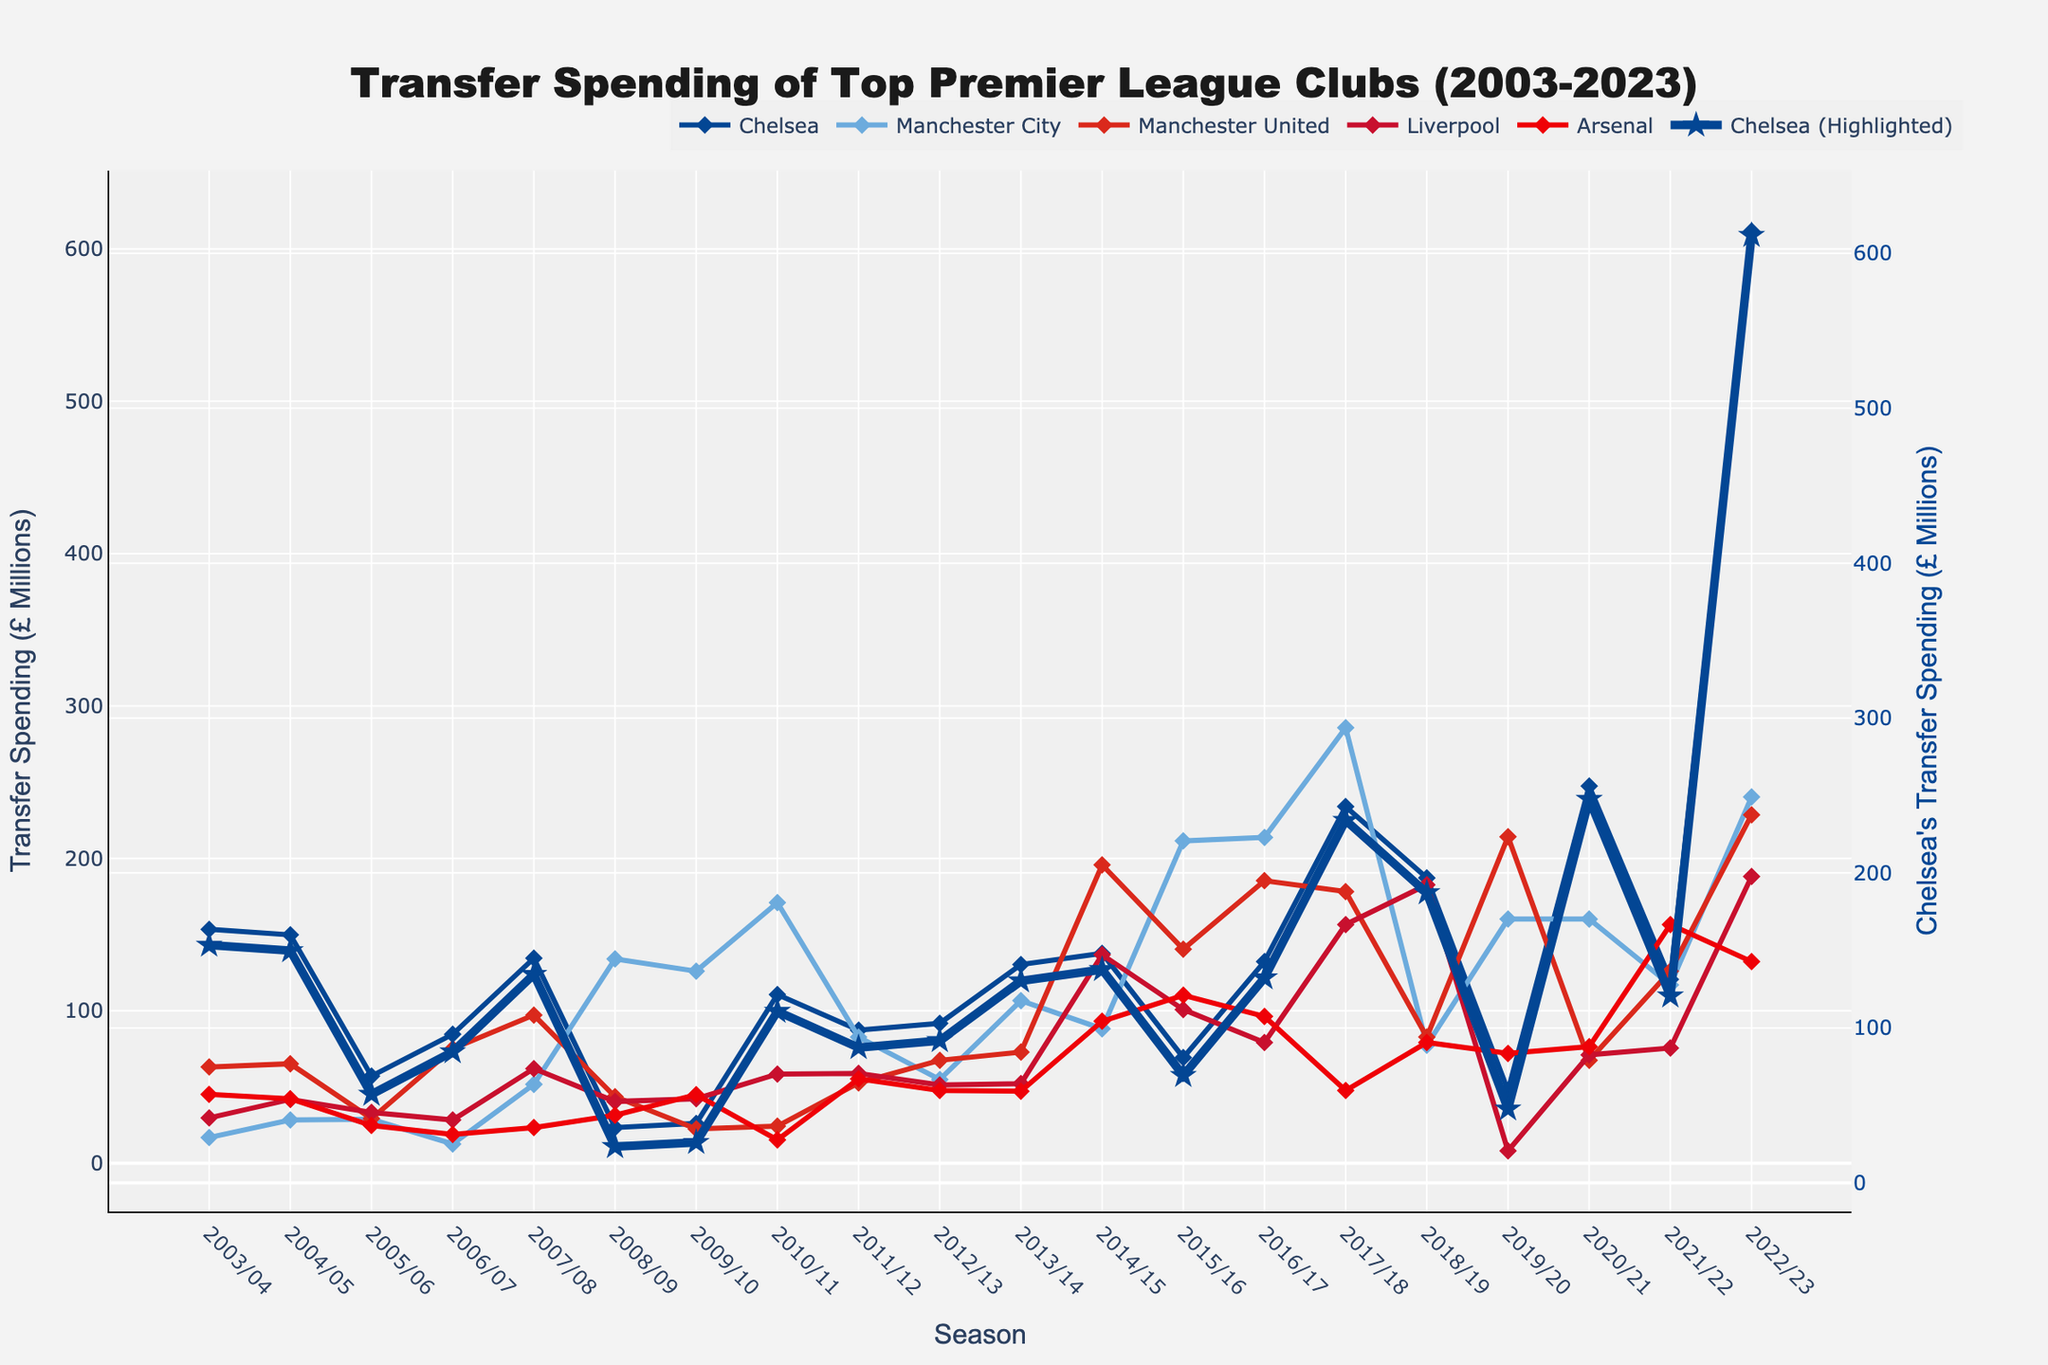Which club had the highest transfer spending in the 2022/23 season? Look at the end points of the lines on the graph for the 2022/23 season. Chelsea's line goes up the highest, indicating the highest spending.
Answer: Chelsea How did Chelsea's transfer spending in the 2017/18 season compare to Manchester City's in the same season? Find the points on the graph for both clubs in the 2017/18 season. Chelsea had higher spending as indicated by a higher point on the graph than Manchester City.
Answer: Chelsea had higher spending What is the trend of Liverpool's transfer spending from 2016/17 to 2019/20? Follow Liverpool's line on the graph from 2016/17 to 2019/20. The graph shows a general downward trend with some fluctuations, indicating decreasing spending.
Answer: Decreasing trend Which season did Arsenal have their lowest transfer spending in the last 20 years? Identify the lowest point on Arsenal's line over the entire period. The lowest point is in the 2010/11 season.
Answer: 2010/11 What is the average transfer spending of Chelsea between 2010/11 and 2014/15? Sum Chelsea's transfer spending in the seasons from 2010/11 to 2014/15 and divide by the number of seasons. (110.7 + 87.3 + 91.8 + 130.35 + 137.7) / 5 = 111.57
Answer: 111.57 In which seasons did Manchester United and Liverpool have almost equal transfer spending? Look for points where the lines for Manchester United and Liverpool are close together or overlapping. The 2010/11 season shows both clubs near the same level.
Answer: 2010/11 Does any club show a significant increase in transfer spending in the 2020/21 season? Look for a sharp upward trend in any club's line in the 2020/21 season. Chelsea's line shows a significant increase in this season.
Answer: Chelsea How does Chelsea's transfer spending in the 2003/04 season compare to their spending in the 2019/20 season? Compare the heights of Chelsea's points in these two seasons. Spending is much higher in 2003/04 compared to 2019/20 as indicated by the higher point in 2003/04.
Answer: Higher in 2003/04 What is the range of Manchester City's transfer spending values over the last 20 years? Identify the highest and lowest points on Manchester City's line. The highest is in 2017/18 (285.75) and the lowest is in 2006/07 (12.6). Subtract the lowest from the highest, 285.75 - 12.6 = 273.15
Answer: 273.15 